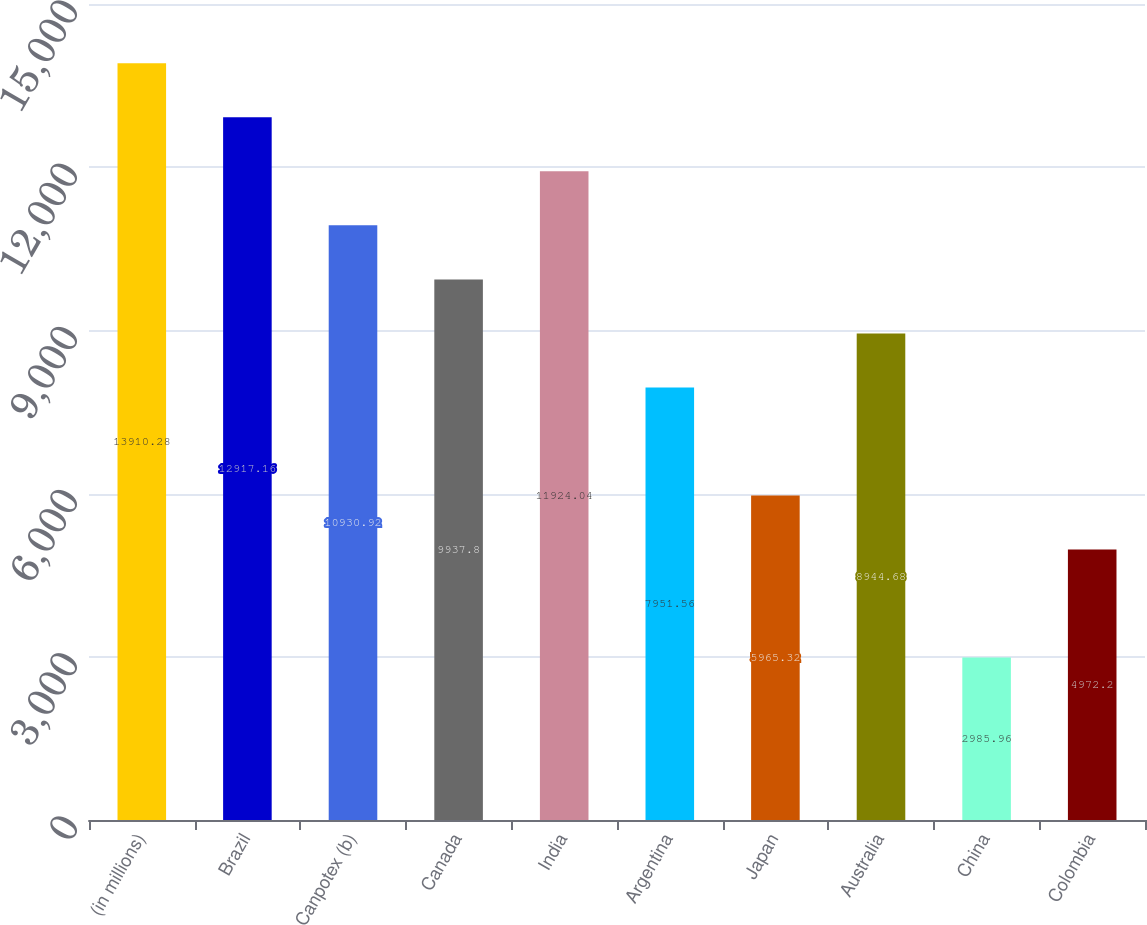Convert chart to OTSL. <chart><loc_0><loc_0><loc_500><loc_500><bar_chart><fcel>(in millions)<fcel>Brazil<fcel>Canpotex (b)<fcel>Canada<fcel>India<fcel>Argentina<fcel>Japan<fcel>Australia<fcel>China<fcel>Colombia<nl><fcel>13910.3<fcel>12917.2<fcel>10930.9<fcel>9937.8<fcel>11924<fcel>7951.56<fcel>5965.32<fcel>8944.68<fcel>2985.96<fcel>4972.2<nl></chart> 